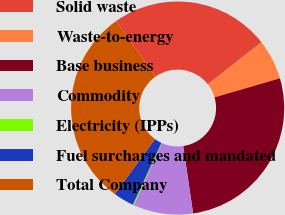<chart> <loc_0><loc_0><loc_500><loc_500><pie_chart><fcel>Solid waste<fcel>Waste-to-energy<fcel>Base business<fcel>Commodity<fcel>Electricity (IPPs)<fcel>Fuel surcharges and mandated<fcel>Total Company<nl><fcel>24.22%<fcel>6.09%<fcel>27.18%<fcel>9.06%<fcel>0.17%<fcel>3.13%<fcel>30.15%<nl></chart> 